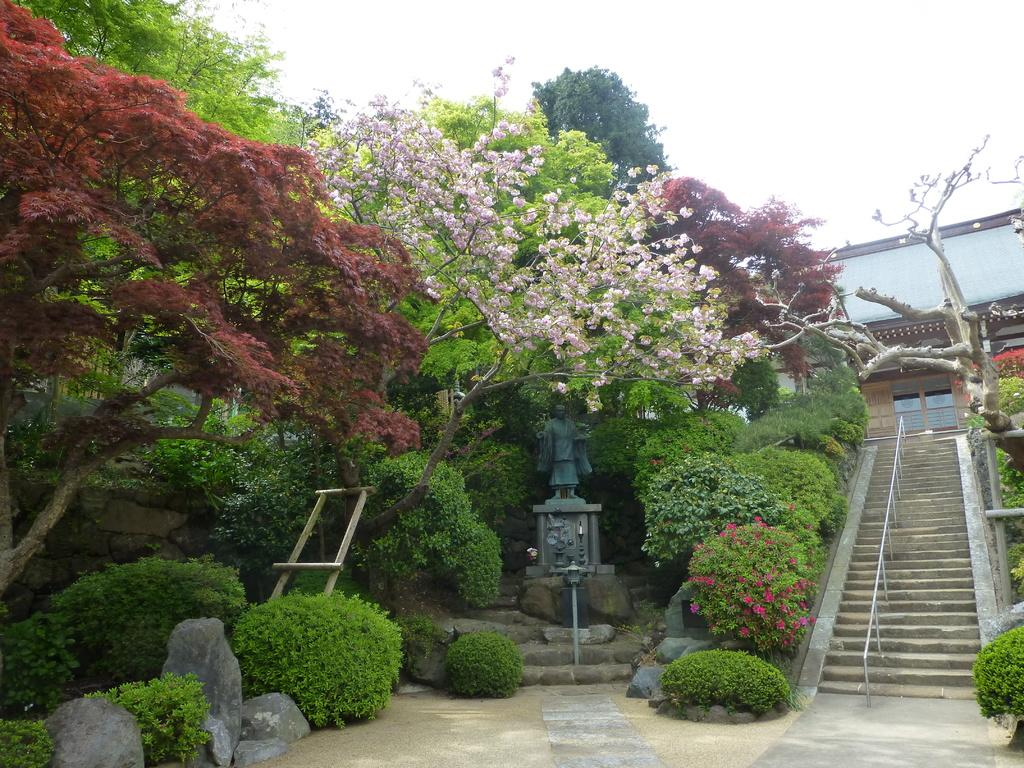What type of structure can be seen in the image? There is a building in the image. How can one access the building? There are stairs leading to the building. Is there any artwork or sculpture in the image? Yes, there is a statue of a person in the image. What type of natural environment is visible in the image? There are a lot of trees present in the image. What type of zinc is present in the image? There is no zinc present in the image. What direction is the railway pointing in the image? There is no railway present in the image. 